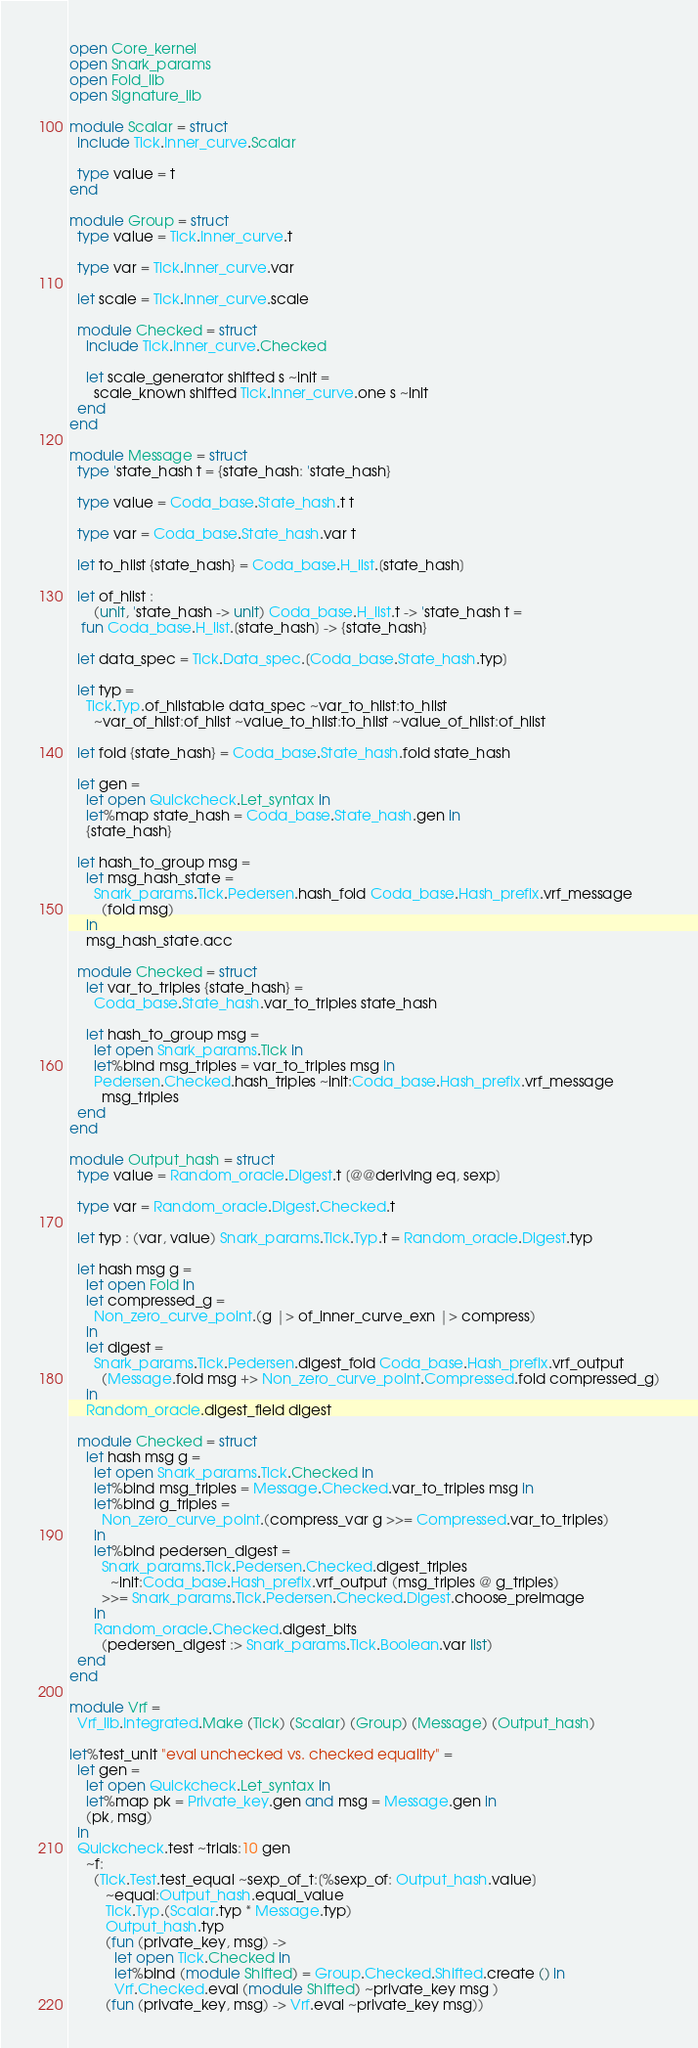<code> <loc_0><loc_0><loc_500><loc_500><_OCaml_>open Core_kernel
open Snark_params
open Fold_lib
open Signature_lib

module Scalar = struct
  include Tick.Inner_curve.Scalar

  type value = t
end

module Group = struct
  type value = Tick.Inner_curve.t

  type var = Tick.Inner_curve.var

  let scale = Tick.Inner_curve.scale

  module Checked = struct
    include Tick.Inner_curve.Checked

    let scale_generator shifted s ~init =
      scale_known shifted Tick.Inner_curve.one s ~init
  end
end

module Message = struct
  type 'state_hash t = {state_hash: 'state_hash}

  type value = Coda_base.State_hash.t t

  type var = Coda_base.State_hash.var t

  let to_hlist {state_hash} = Coda_base.H_list.[state_hash]

  let of_hlist :
      (unit, 'state_hash -> unit) Coda_base.H_list.t -> 'state_hash t =
   fun Coda_base.H_list.[state_hash] -> {state_hash}

  let data_spec = Tick.Data_spec.[Coda_base.State_hash.typ]

  let typ =
    Tick.Typ.of_hlistable data_spec ~var_to_hlist:to_hlist
      ~var_of_hlist:of_hlist ~value_to_hlist:to_hlist ~value_of_hlist:of_hlist

  let fold {state_hash} = Coda_base.State_hash.fold state_hash

  let gen =
    let open Quickcheck.Let_syntax in
    let%map state_hash = Coda_base.State_hash.gen in
    {state_hash}

  let hash_to_group msg =
    let msg_hash_state =
      Snark_params.Tick.Pedersen.hash_fold Coda_base.Hash_prefix.vrf_message
        (fold msg)
    in
    msg_hash_state.acc

  module Checked = struct
    let var_to_triples {state_hash} =
      Coda_base.State_hash.var_to_triples state_hash

    let hash_to_group msg =
      let open Snark_params.Tick in
      let%bind msg_triples = var_to_triples msg in
      Pedersen.Checked.hash_triples ~init:Coda_base.Hash_prefix.vrf_message
        msg_triples
  end
end

module Output_hash = struct
  type value = Random_oracle.Digest.t [@@deriving eq, sexp]

  type var = Random_oracle.Digest.Checked.t

  let typ : (var, value) Snark_params.Tick.Typ.t = Random_oracle.Digest.typ

  let hash msg g =
    let open Fold in
    let compressed_g =
      Non_zero_curve_point.(g |> of_inner_curve_exn |> compress)
    in
    let digest =
      Snark_params.Tick.Pedersen.digest_fold Coda_base.Hash_prefix.vrf_output
        (Message.fold msg +> Non_zero_curve_point.Compressed.fold compressed_g)
    in
    Random_oracle.digest_field digest

  module Checked = struct
    let hash msg g =
      let open Snark_params.Tick.Checked in
      let%bind msg_triples = Message.Checked.var_to_triples msg in
      let%bind g_triples =
        Non_zero_curve_point.(compress_var g >>= Compressed.var_to_triples)
      in
      let%bind pedersen_digest =
        Snark_params.Tick.Pedersen.Checked.digest_triples
          ~init:Coda_base.Hash_prefix.vrf_output (msg_triples @ g_triples)
        >>= Snark_params.Tick.Pedersen.Checked.Digest.choose_preimage
      in
      Random_oracle.Checked.digest_bits
        (pedersen_digest :> Snark_params.Tick.Boolean.var list)
  end
end

module Vrf =
  Vrf_lib.Integrated.Make (Tick) (Scalar) (Group) (Message) (Output_hash)

let%test_unit "eval unchecked vs. checked equality" =
  let gen =
    let open Quickcheck.Let_syntax in
    let%map pk = Private_key.gen and msg = Message.gen in
    (pk, msg)
  in
  Quickcheck.test ~trials:10 gen
    ~f:
      (Tick.Test.test_equal ~sexp_of_t:[%sexp_of: Output_hash.value]
         ~equal:Output_hash.equal_value
         Tick.Typ.(Scalar.typ * Message.typ)
         Output_hash.typ
         (fun (private_key, msg) ->
           let open Tick.Checked in
           let%bind (module Shifted) = Group.Checked.Shifted.create () in
           Vrf.Checked.eval (module Shifted) ~private_key msg )
         (fun (private_key, msg) -> Vrf.eval ~private_key msg))
</code> 